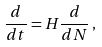<formula> <loc_0><loc_0><loc_500><loc_500>\frac { d } { d t } = H \frac { d } { d N } \, ,</formula> 